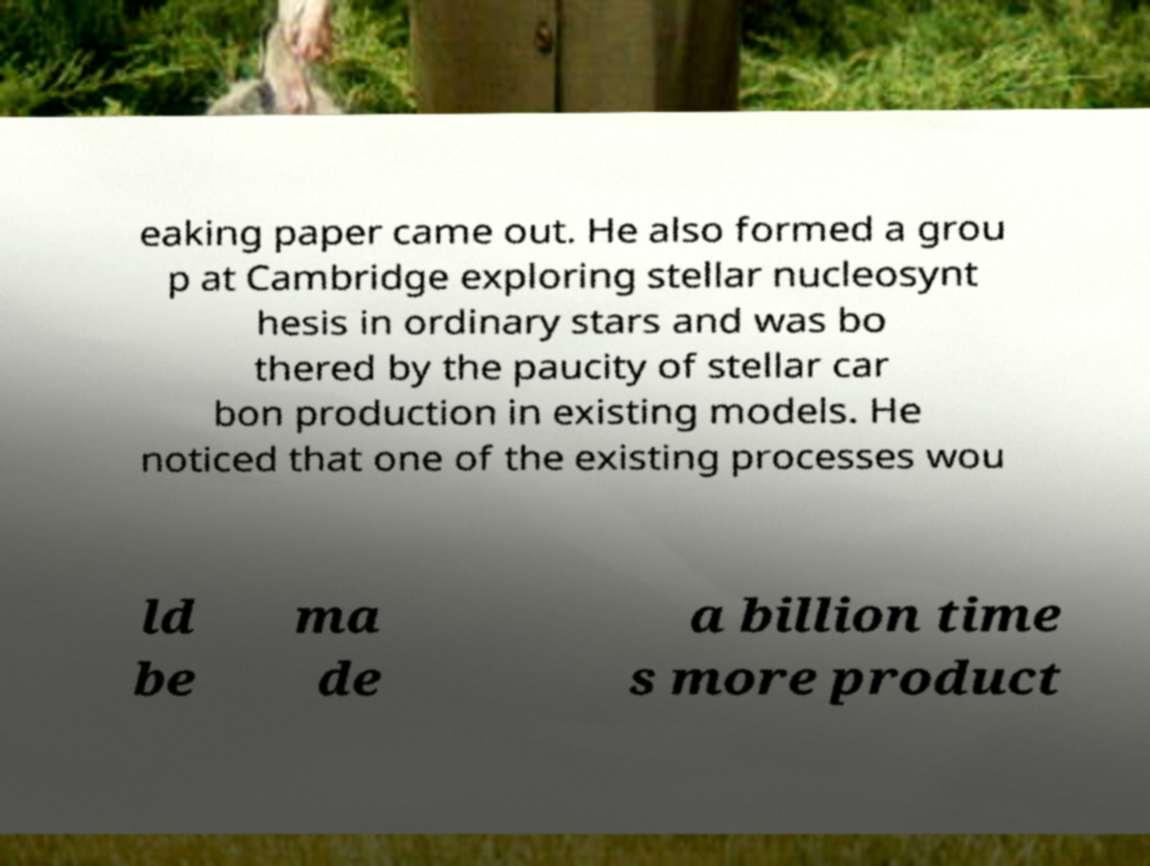Please identify and transcribe the text found in this image. eaking paper came out. He also formed a grou p at Cambridge exploring stellar nucleosynt hesis in ordinary stars and was bo thered by the paucity of stellar car bon production in existing models. He noticed that one of the existing processes wou ld be ma de a billion time s more product 